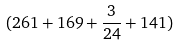<formula> <loc_0><loc_0><loc_500><loc_500>( 2 6 1 + 1 6 9 + \frac { 3 } { 2 4 } + 1 4 1 )</formula> 